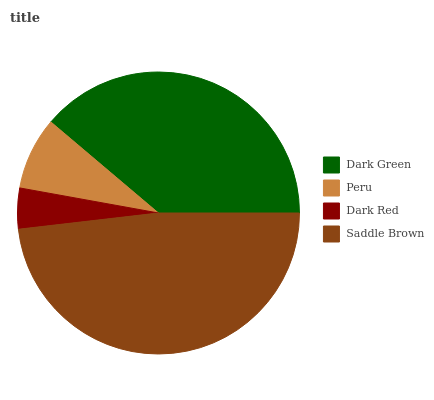Is Dark Red the minimum?
Answer yes or no. Yes. Is Saddle Brown the maximum?
Answer yes or no. Yes. Is Peru the minimum?
Answer yes or no. No. Is Peru the maximum?
Answer yes or no. No. Is Dark Green greater than Peru?
Answer yes or no. Yes. Is Peru less than Dark Green?
Answer yes or no. Yes. Is Peru greater than Dark Green?
Answer yes or no. No. Is Dark Green less than Peru?
Answer yes or no. No. Is Dark Green the high median?
Answer yes or no. Yes. Is Peru the low median?
Answer yes or no. Yes. Is Peru the high median?
Answer yes or no. No. Is Dark Green the low median?
Answer yes or no. No. 